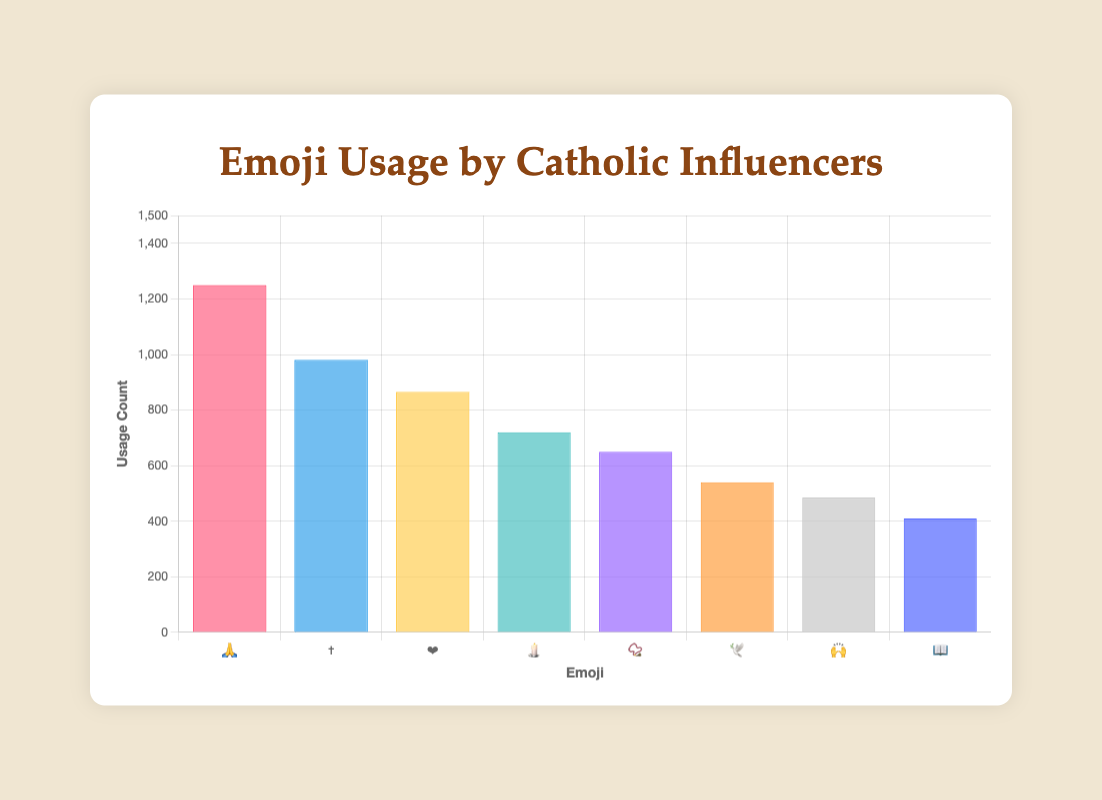Which emoji has the highest usage count? Looking at the bar chart, the emoji with the highest bar is the "🙏" emoji, indicating it has the highest usage count.
Answer: 🙏 How many total emoji usage counts are represented by Bishop Robert Barron and Sister Miriam James Heidland combined? Bishop Robert Barron has a usage count of 980 (✝️) and Sister Miriam James Heidland has a count of 720 (🕯️). Adding these together: 980 + 720 = 1700.
Answer: 1700 Which influencer uses the "📿" emoji the most? Observing the tooltips or the labels, Matt Fradd is associated with the "📿" emoji, indicating he is the user with the highest count for this emoji.
Answer: Matt Fradd Which emoji is used more frequently, "🙌" by Jason Evert or "📖" by Scott Hahn? Reference the chart to compare the heights of the bars for "🙌" (Jason Evert) and "📖" (Scott Hahn). "🙌" has a count of 485, while "📖" has a count of 410. Therefore, "🙌" by Jason Evert is used more frequently.
Answer: 🙌 What is the average usage count of the emojis represented in the chart? First, sum the usage counts: 1250 (🙏) + 980 (✝️) + 865 (❤️) + 720 (🕯️) + 650 (📿) + 540 (🕊️) + 485 (🙌) + 410 (📖) = 5900. There are 8 emojis, so the average is 5900 / 8 = 737.5.
Answer: 737.5 Which two emojis are used least often? By observing the chart, the emojis with the smallest bars are "📖" (410) and "🙌" (485).
Answer: 📖 and 🙌 What is the total number of emojis used by Leah Darrow and Jason Evert together? Leah Darrow uses the "❤️" emoji with a count of 865, and Jason Evert uses the "🙌" emoji with a count of 485. Summing these gives: 865 + 485 = 1350.
Answer: 1350 Are there any influencers who use an emoji count below 500? If so, who? Reviewing the counts of the bars, the only emojis below 500 usages are "📖" (Scott Hahn) and "🙌" (Jason Evert), thus the influencers are Scott Hahn and Jason Evert.
Answer: Scott Hahn and Jason Evert 